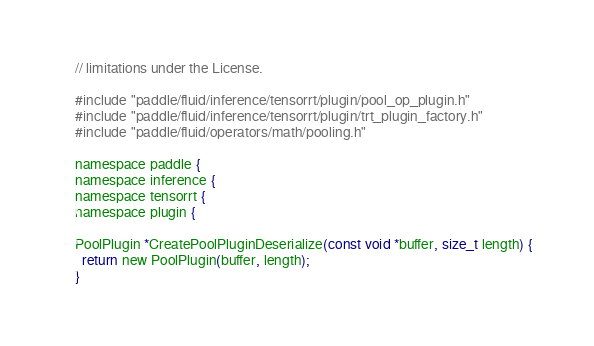Convert code to text. <code><loc_0><loc_0><loc_500><loc_500><_Cuda_>// limitations under the License.

#include "paddle/fluid/inference/tensorrt/plugin/pool_op_plugin.h"
#include "paddle/fluid/inference/tensorrt/plugin/trt_plugin_factory.h"
#include "paddle/fluid/operators/math/pooling.h"

namespace paddle {
namespace inference {
namespace tensorrt {
namespace plugin {

PoolPlugin *CreatePoolPluginDeserialize(const void *buffer, size_t length) {
  return new PoolPlugin(buffer, length);
}</code> 